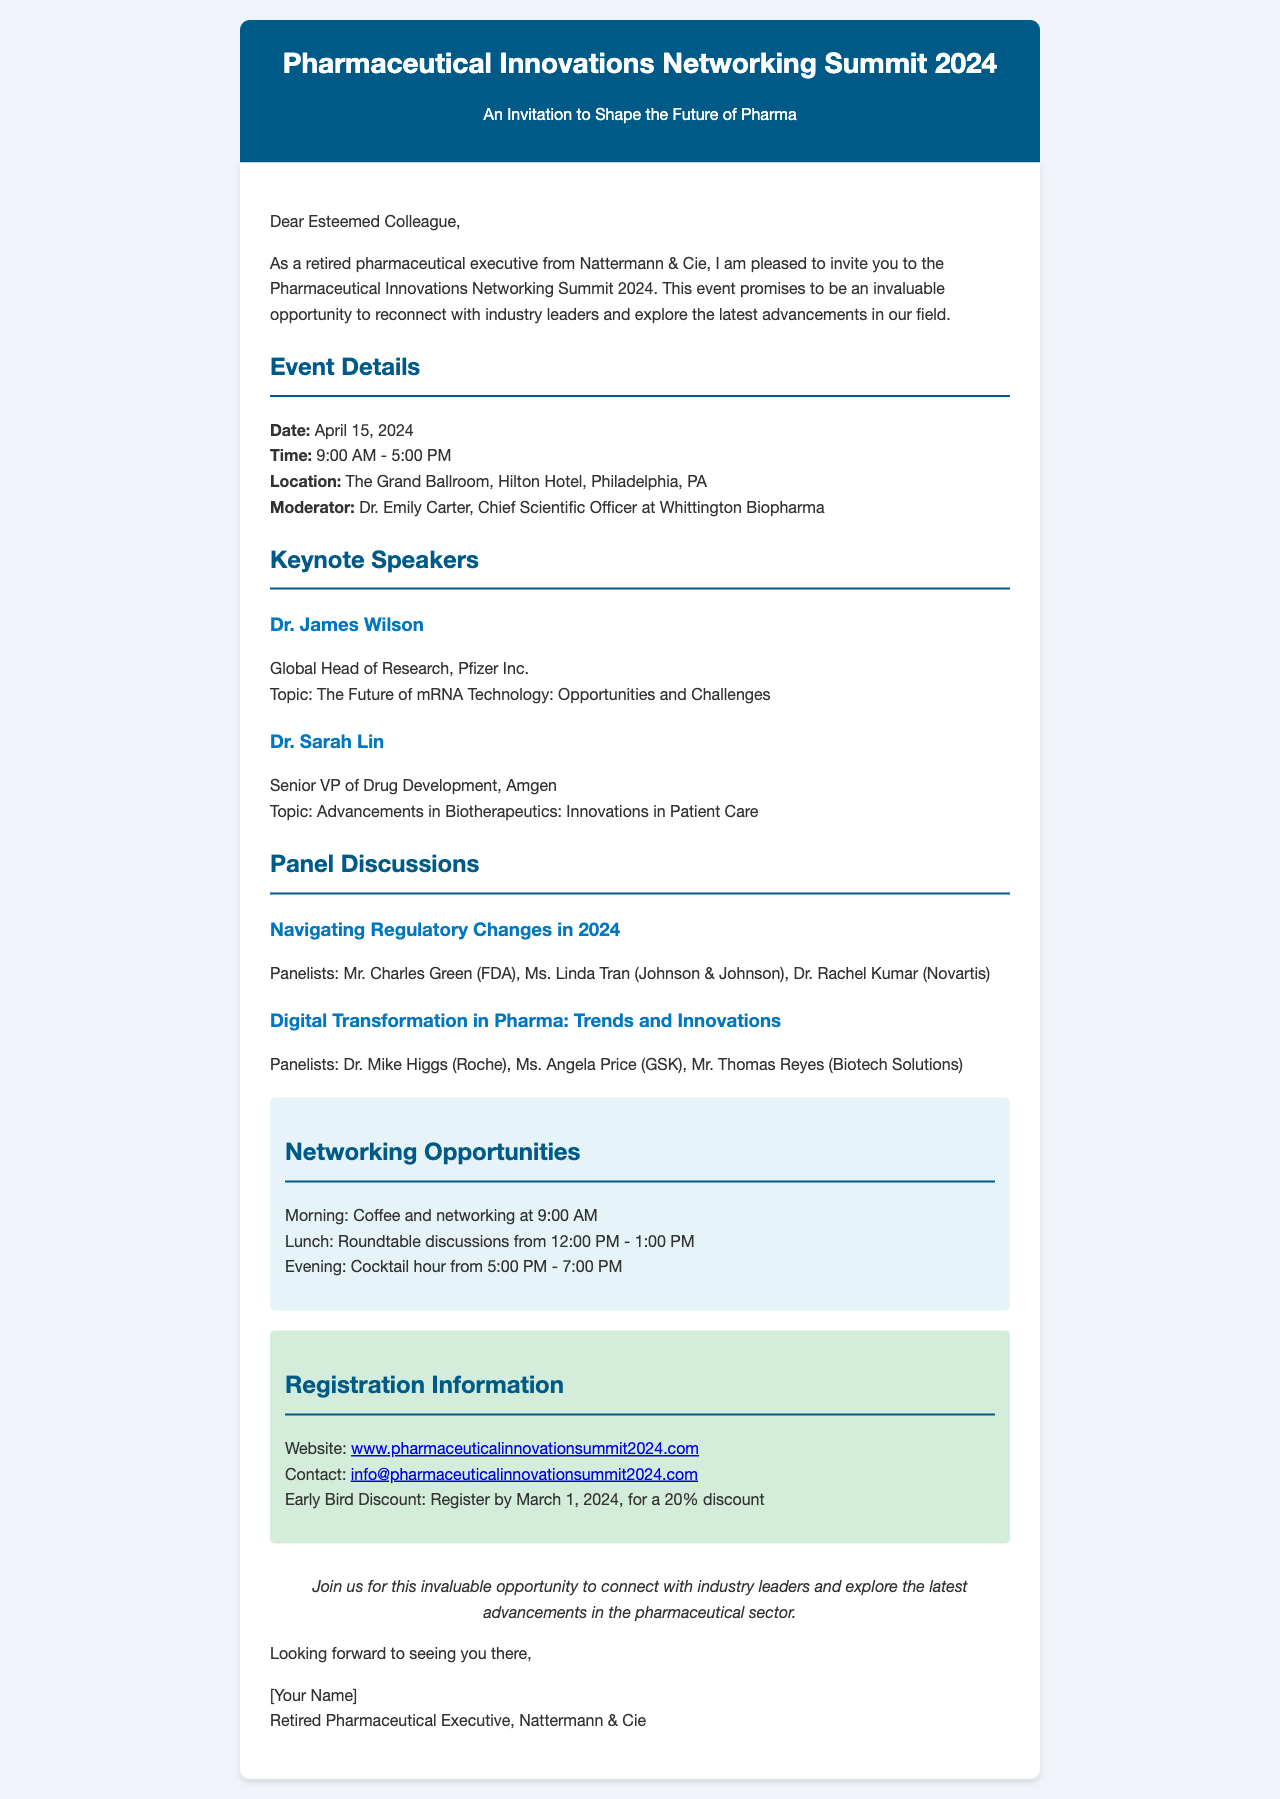What is the date of the event? The date of the event is specified in the document as April 15, 2024.
Answer: April 15, 2024 Who is the moderator for the event? The document explicitly mentions Dr. Emily Carter as the moderator for the event.
Answer: Dr. Emily Carter What time does the event start? The start time of the event is mentioned as 9:00 AM.
Answer: 9:00 AM How long is the cocktail hour? The cocktail hour is scheduled from 5:00 PM to 7:00 PM, indicating a duration of two hours.
Answer: Two hours What discount is offered for early registration? The document states a 20% discount for those who register by March 1, 2024.
Answer: 20% discount What is one of the topics of the keynote speeches? The topics of the keynote speeches include "The Future of mRNA Technology: Opportunities and Challenges."
Answer: The Future of mRNA Technology: Opportunities and Challenges Which hotel is hosting the event? The document identifies The Grand Ballroom, Hilton Hotel, as the event location.
Answer: Hilton Hotel Who is speaking on advancements in biotherapeutics? Dr. Sarah Lin is the one speaking on innovations in patient care related to biotherapeutics.
Answer: Dr. Sarah Lin What is the email for contact regarding the event? The contact email provided in the document is info@pharmaceuticalinnovationsummit2024.com.
Answer: info@pharmaceuticalinnovationsummit2024.com 